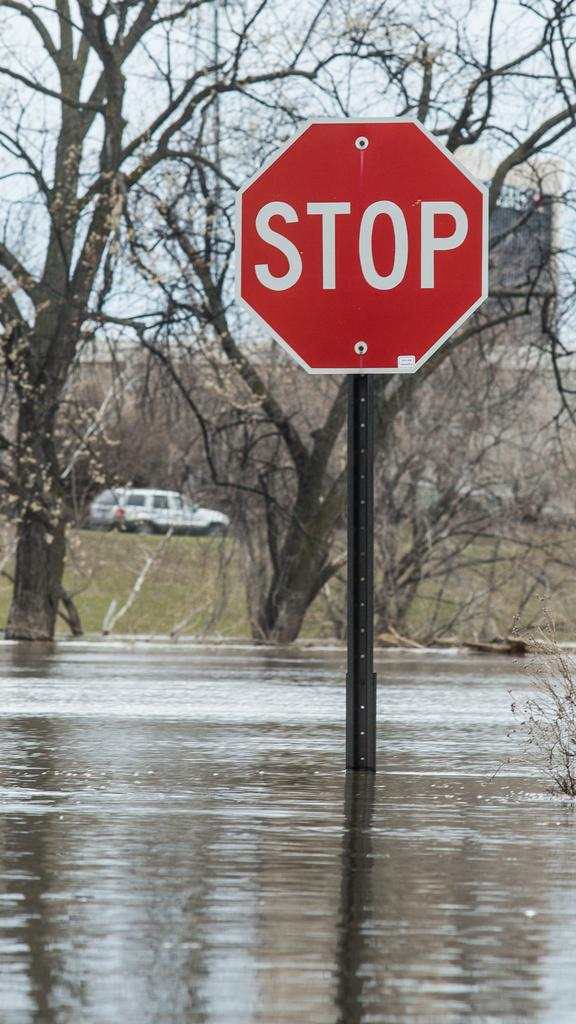<image>
Write a terse but informative summary of the picture. a stop sign in red with water under it 